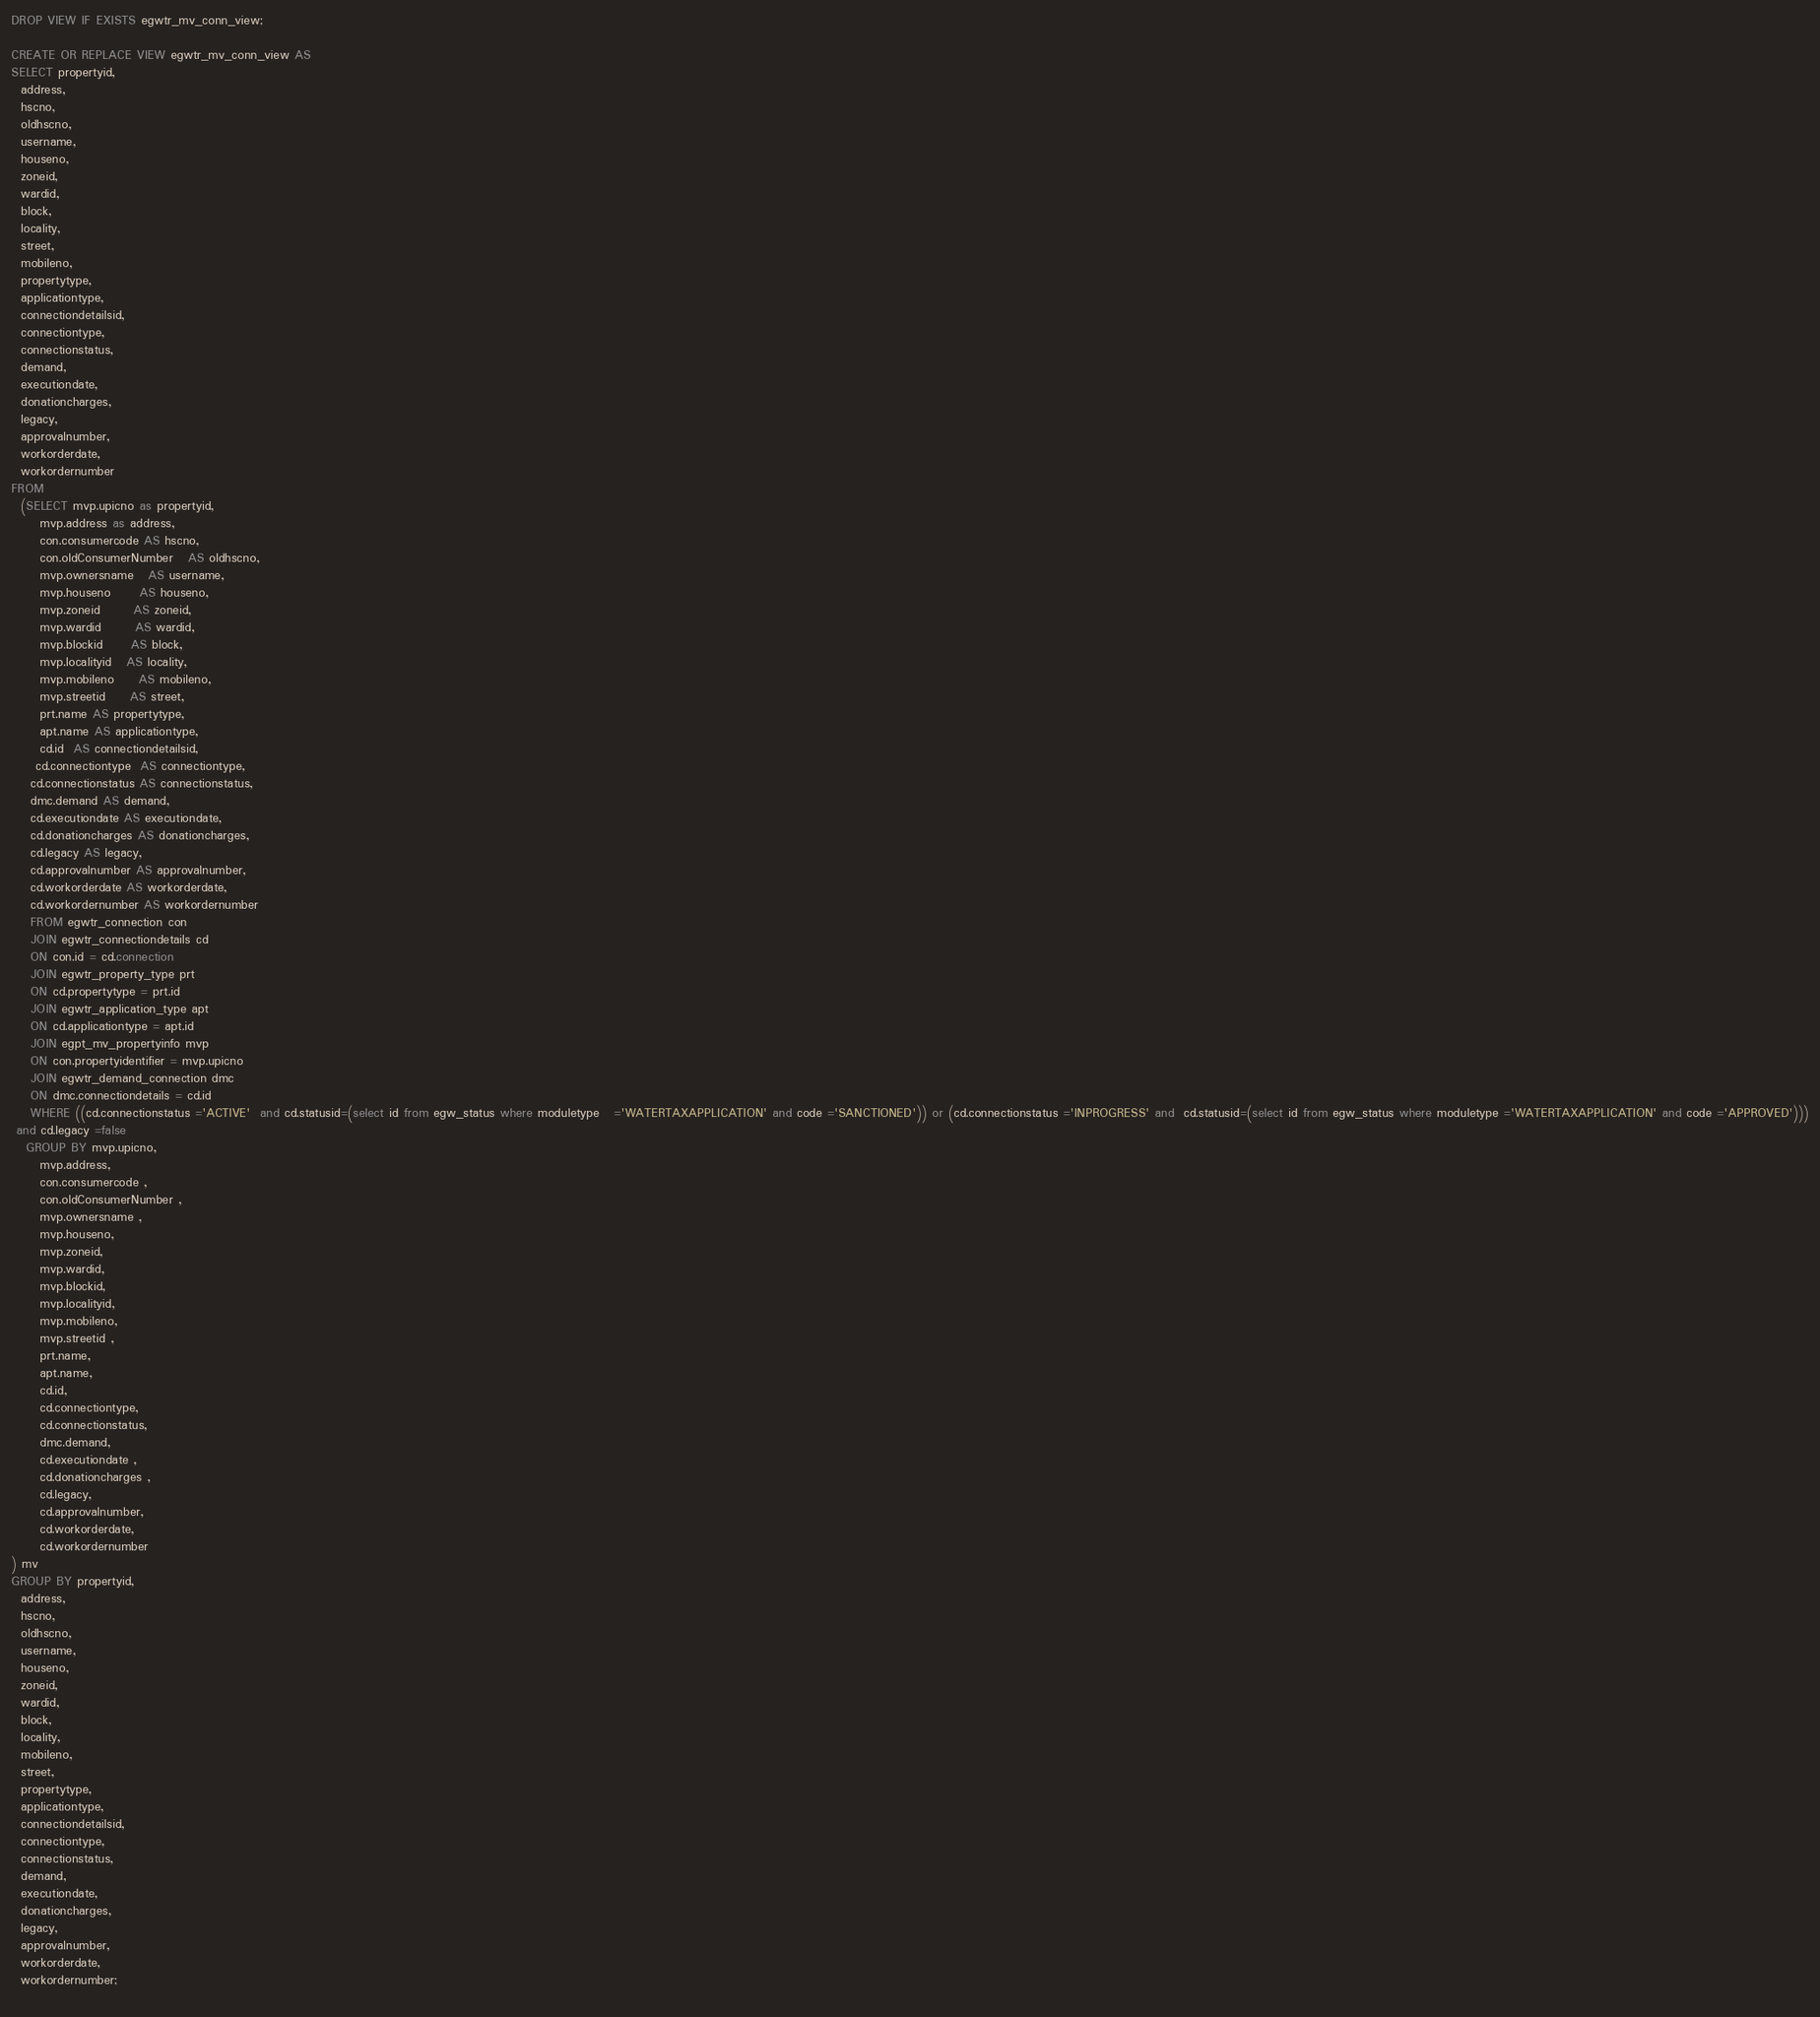<code> <loc_0><loc_0><loc_500><loc_500><_SQL_>DROP VIEW IF EXISTS egwtr_mv_conn_view;

CREATE OR REPLACE VIEW egwtr_mv_conn_view AS
SELECT propertyid,
  address,
  hscno,
  oldhscno,
  username,
  houseno,
  zoneid,
  wardid,
  block,
  locality,
  street,
  mobileno,
  propertytype,
  applicationtype,
  connectiondetailsid,
  connectiontype,
  connectionstatus,
  demand,
  executiondate,
  donationcharges,
  legacy,
  approvalnumber,
  workorderdate,
  workordernumber
FROM
  (SELECT mvp.upicno as propertyid,
      mvp.address as address,
      con.consumercode AS hscno,
      con.oldConsumerNumber   AS oldhscno,
      mvp.ownersname   AS username,
      mvp.houseno      AS houseno,
      mvp.zoneid       AS zoneid,
      mvp.wardid       AS wardid,
      mvp.blockid      AS block,
      mvp.localityid   AS locality,
      mvp.mobileno     AS mobileno,
      mvp.streetid     AS street,
      prt.name AS propertytype,
      apt.name AS applicationtype,
      cd.id  AS connectiondetailsid,
     cd.connectiontype  AS connectiontype,
    cd.connectionstatus AS connectionstatus,
    dmc.demand AS demand,
    cd.executiondate AS executiondate,
    cd.donationcharges AS donationcharges,
    cd.legacy AS legacy,
    cd.approvalnumber AS approvalnumber,
    cd.workorderdate AS workorderdate,
    cd.workordernumber AS workordernumber
    FROM egwtr_connection con
    JOIN egwtr_connectiondetails cd
    ON con.id = cd.connection
    JOIN egwtr_property_type prt
    ON cd.propertytype = prt.id
    JOIN egwtr_application_type apt
    ON cd.applicationtype = apt.id
    JOIN egpt_mv_propertyinfo mvp
    ON con.propertyidentifier = mvp.upicno
    JOIN egwtr_demand_connection dmc
    ON dmc.connectiondetails = cd.id
    WHERE ((cd.connectionstatus ='ACTIVE'  and cd.statusid=(select id from egw_status where moduletype   ='WATERTAXAPPLICATION' and code ='SANCTIONED')) or (cd.connectionstatus ='INPROGRESS' and  cd.statusid=(select id from egw_status where moduletype ='WATERTAXAPPLICATION' and code ='APPROVED')))
 and cd.legacy =false 
   GROUP BY mvp.upicno,
      mvp.address,
      con.consumercode ,
      con.oldConsumerNumber ,
      mvp.ownersname ,
      mvp.houseno,
      mvp.zoneid,
      mvp.wardid,
      mvp.blockid,
      mvp.localityid,
      mvp.mobileno,
      mvp.streetid ,
      prt.name,
      apt.name,
      cd.id,
      cd.connectiontype,
      cd.connectionstatus,
      dmc.demand,
      cd.executiondate ,
      cd.donationcharges ,
      cd.legacy,
      cd.approvalnumber,
      cd.workorderdate,
      cd.workordernumber
) mv
GROUP BY propertyid,
  address,
  hscno,
  oldhscno,
  username,
  houseno,
  zoneid,
  wardid,
  block,
  locality,
  mobileno,
  street,
  propertytype,
  applicationtype,
  connectiondetailsid,
  connectiontype,
  connectionstatus,
  demand,
  executiondate,
  donationcharges,
  legacy,
  approvalnumber,
  workorderdate,
  workordernumber;
                                                                                                                       </code> 